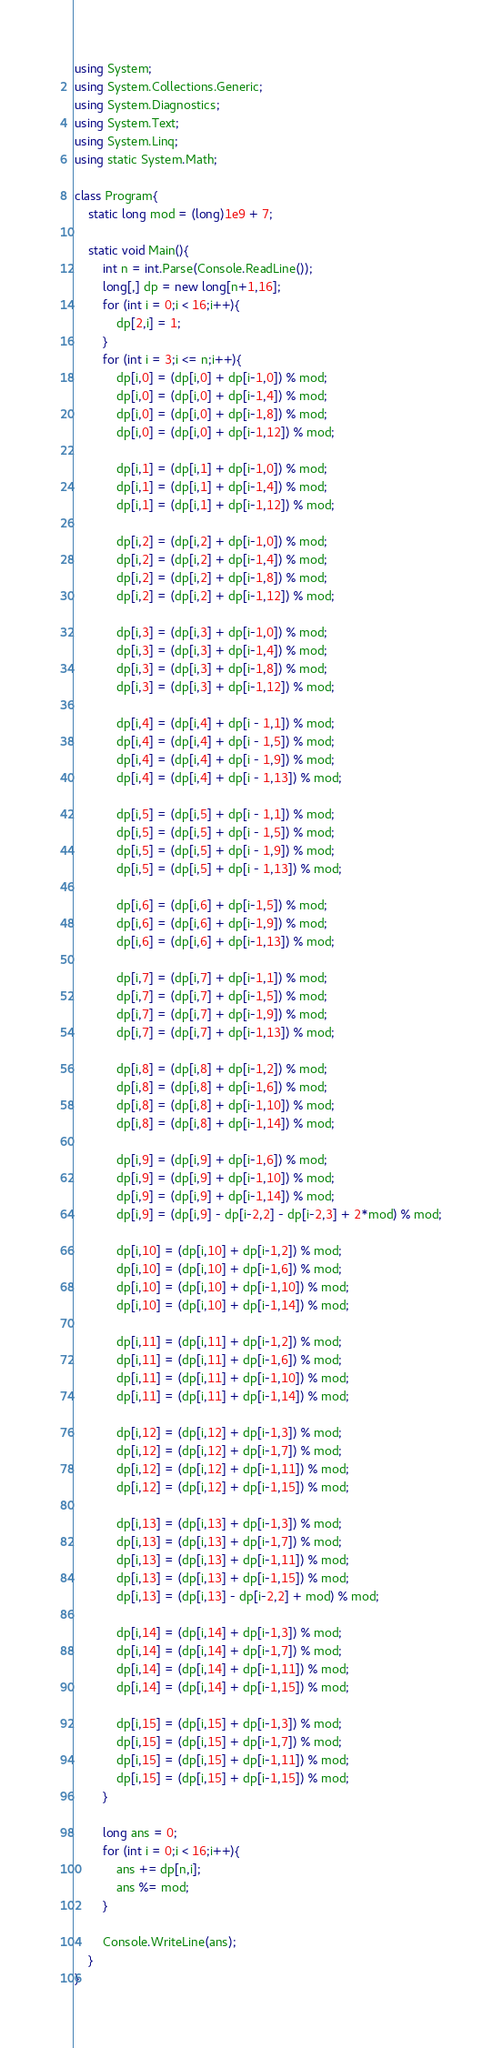<code> <loc_0><loc_0><loc_500><loc_500><_C#_>using System;
using System.Collections.Generic;
using System.Diagnostics;
using System.Text;
using System.Linq;
using static System.Math;

class Program{
    static long mod = (long)1e9 + 7;

    static void Main(){
        int n = int.Parse(Console.ReadLine());
        long[,] dp = new long[n+1,16];
        for (int i = 0;i < 16;i++){
            dp[2,i] = 1;
        }
        for (int i = 3;i <= n;i++){
            dp[i,0] = (dp[i,0] + dp[i-1,0]) % mod;
            dp[i,0] = (dp[i,0] + dp[i-1,4]) % mod;
            dp[i,0] = (dp[i,0] + dp[i-1,8]) % mod;
            dp[i,0] = (dp[i,0] + dp[i-1,12]) % mod;

            dp[i,1] = (dp[i,1] + dp[i-1,0]) % mod;
            dp[i,1] = (dp[i,1] + dp[i-1,4]) % mod;
            dp[i,1] = (dp[i,1] + dp[i-1,12]) % mod;

            dp[i,2] = (dp[i,2] + dp[i-1,0]) % mod;
            dp[i,2] = (dp[i,2] + dp[i-1,4]) % mod;
            dp[i,2] = (dp[i,2] + dp[i-1,8]) % mod;
            dp[i,2] = (dp[i,2] + dp[i-1,12]) % mod;

            dp[i,3] = (dp[i,3] + dp[i-1,0]) % mod;
            dp[i,3] = (dp[i,3] + dp[i-1,4]) % mod;
            dp[i,3] = (dp[i,3] + dp[i-1,8]) % mod;
            dp[i,3] = (dp[i,3] + dp[i-1,12]) % mod;

            dp[i,4] = (dp[i,4] + dp[i - 1,1]) % mod;
            dp[i,4] = (dp[i,4] + dp[i - 1,5]) % mod;
            dp[i,4] = (dp[i,4] + dp[i - 1,9]) % mod;
            dp[i,4] = (dp[i,4] + dp[i - 1,13]) % mod;

            dp[i,5] = (dp[i,5] + dp[i - 1,1]) % mod;
            dp[i,5] = (dp[i,5] + dp[i - 1,5]) % mod;
            dp[i,5] = (dp[i,5] + dp[i - 1,9]) % mod;
            dp[i,5] = (dp[i,5] + dp[i - 1,13]) % mod;

            dp[i,6] = (dp[i,6] + dp[i-1,5]) % mod;
            dp[i,6] = (dp[i,6] + dp[i-1,9]) % mod;
            dp[i,6] = (dp[i,6] + dp[i-1,13]) % mod;

            dp[i,7] = (dp[i,7] + dp[i-1,1]) % mod;
            dp[i,7] = (dp[i,7] + dp[i-1,5]) % mod;
            dp[i,7] = (dp[i,7] + dp[i-1,9]) % mod;
            dp[i,7] = (dp[i,7] + dp[i-1,13]) % mod;

            dp[i,8] = (dp[i,8] + dp[i-1,2]) % mod;
            dp[i,8] = (dp[i,8] + dp[i-1,6]) % mod;
            dp[i,8] = (dp[i,8] + dp[i-1,10]) % mod;
            dp[i,8] = (dp[i,8] + dp[i-1,14]) % mod;

            dp[i,9] = (dp[i,9] + dp[i-1,6]) % mod;
            dp[i,9] = (dp[i,9] + dp[i-1,10]) % mod;
            dp[i,9] = (dp[i,9] + dp[i-1,14]) % mod;
            dp[i,9] = (dp[i,9] - dp[i-2,2] - dp[i-2,3] + 2*mod) % mod;

            dp[i,10] = (dp[i,10] + dp[i-1,2]) % mod;
            dp[i,10] = (dp[i,10] + dp[i-1,6]) % mod;
            dp[i,10] = (dp[i,10] + dp[i-1,10]) % mod;
            dp[i,10] = (dp[i,10] + dp[i-1,14]) % mod;

            dp[i,11] = (dp[i,11] + dp[i-1,2]) % mod;
            dp[i,11] = (dp[i,11] + dp[i-1,6]) % mod;
            dp[i,11] = (dp[i,11] + dp[i-1,10]) % mod;
            dp[i,11] = (dp[i,11] + dp[i-1,14]) % mod;

            dp[i,12] = (dp[i,12] + dp[i-1,3]) % mod;
            dp[i,12] = (dp[i,12] + dp[i-1,7]) % mod;
            dp[i,12] = (dp[i,12] + dp[i-1,11]) % mod;
            dp[i,12] = (dp[i,12] + dp[i-1,15]) % mod;

            dp[i,13] = (dp[i,13] + dp[i-1,3]) % mod;
            dp[i,13] = (dp[i,13] + dp[i-1,7]) % mod;
            dp[i,13] = (dp[i,13] + dp[i-1,11]) % mod;
            dp[i,13] = (dp[i,13] + dp[i-1,15]) % mod;
            dp[i,13] = (dp[i,13] - dp[i-2,2] + mod) % mod;

            dp[i,14] = (dp[i,14] + dp[i-1,3]) % mod;
            dp[i,14] = (dp[i,14] + dp[i-1,7]) % mod;
            dp[i,14] = (dp[i,14] + dp[i-1,11]) % mod;
            dp[i,14] = (dp[i,14] + dp[i-1,15]) % mod;

            dp[i,15] = (dp[i,15] + dp[i-1,3]) % mod;
            dp[i,15] = (dp[i,15] + dp[i-1,7]) % mod;
            dp[i,15] = (dp[i,15] + dp[i-1,11]) % mod;
            dp[i,15] = (dp[i,15] + dp[i-1,15]) % mod;
        }

        long ans = 0;
        for (int i = 0;i < 16;i++){
            ans += dp[n,i];
            ans %= mod;
        }

        Console.WriteLine(ans);
    }
}
</code> 